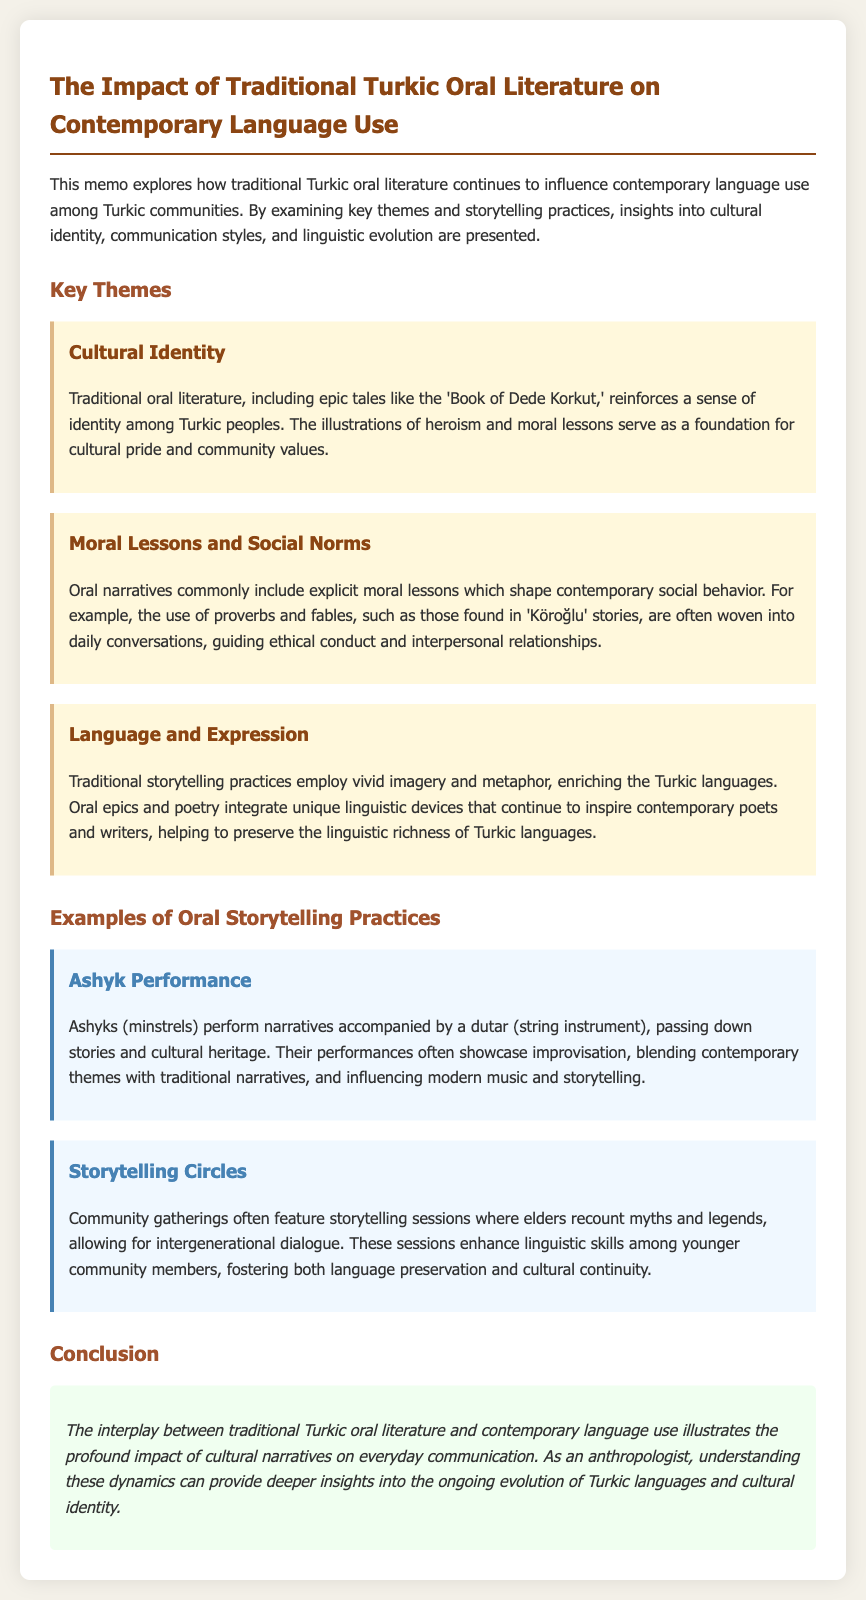What is the title of the memo? The title of the memo is stated at the beginning of the document.
Answer: The Impact of Traditional Turkic Oral Literature on Contemporary Language Use Which epic tale is mentioned as reinforcing cultural identity? The document refers specifically to an epic that illustrates heroism and moral lessons.
Answer: Book of Dede Korkut What are used in daily conversations to guide ethical conduct? The document states that these elements are often woven into everyday interactions.
Answer: Proverbs and fables What performance practice involves improvisation in storytelling? The document describes a specific type of performance that combines contemporary and traditional themes.
Answer: Ashyk Performance What is a primary function of storytelling circles? The memos explain the role of these gatherings in cultural transmission and language skills.
Answer: Intergenerational dialogue What effect does traditional storytelling have on contemporary poets? The document mentions how storytelling influences the work of modern literary figures.
Answer: Inspiring What color represents the "Cultural Identity" section? The formatting in the document indicates a specific visual theme for this part.
Answer: Brown How does oral literature enrich Turkic languages? The memo explains the impact of storytelling practices on linguistic development.
Answer: Vivid imagery and metaphor 